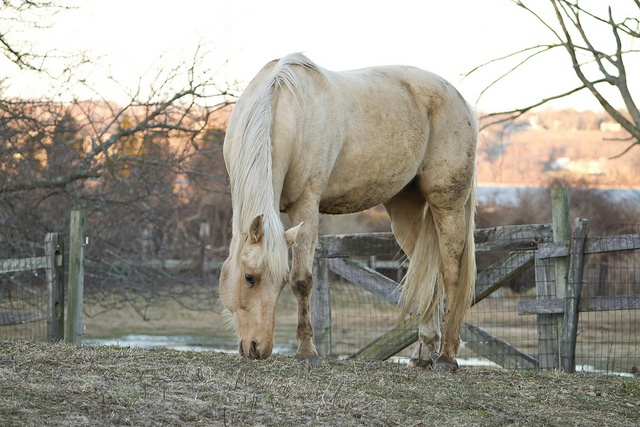Describe the objects in this image and their specific colors. I can see a horse in ivory, darkgray, gray, and lightgray tones in this image. 